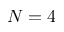<formula> <loc_0><loc_0><loc_500><loc_500>N = 4</formula> 